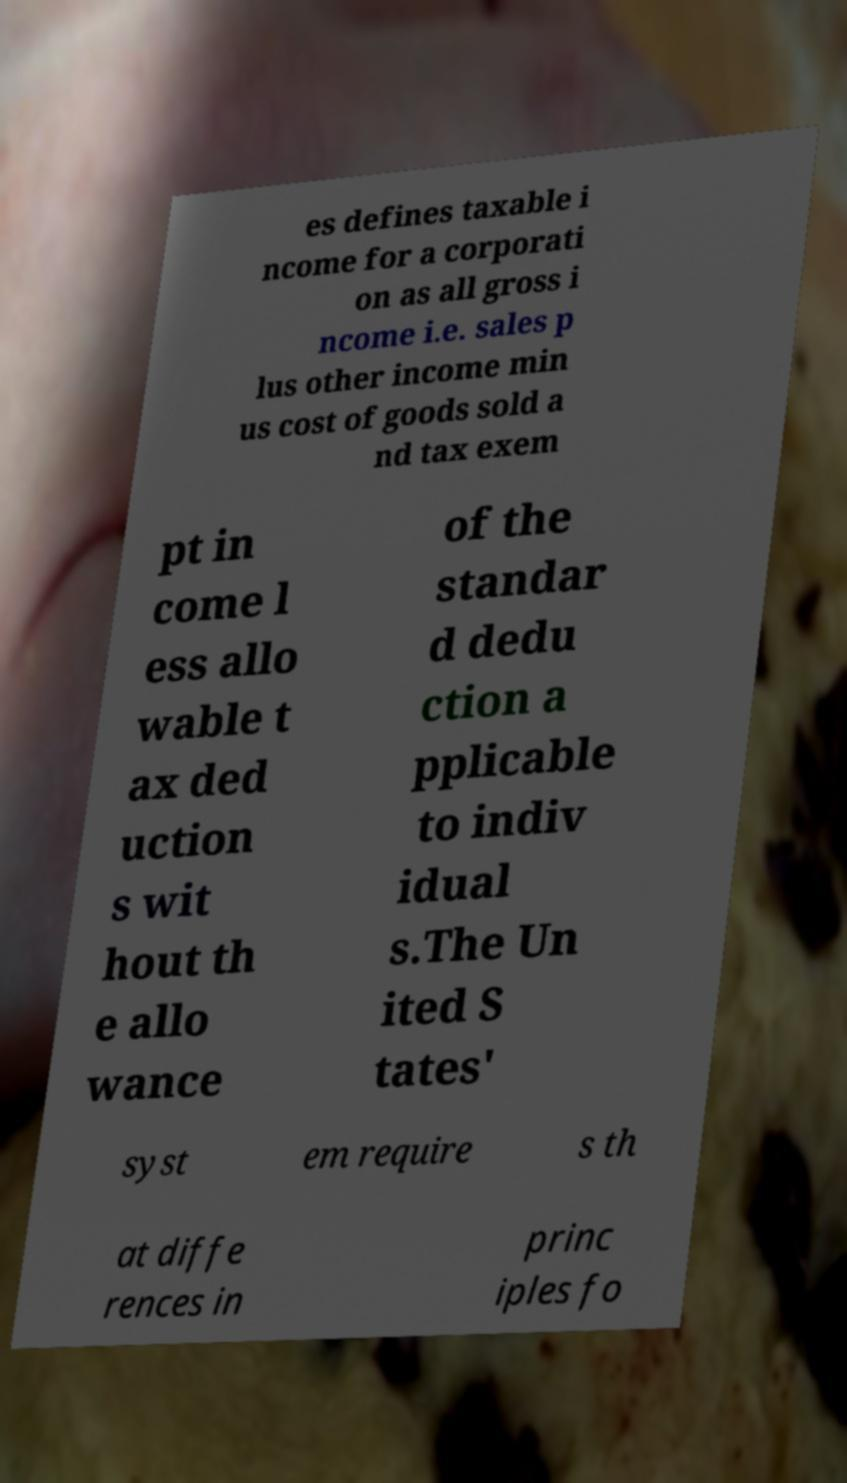Please read and relay the text visible in this image. What does it say? es defines taxable i ncome for a corporati on as all gross i ncome i.e. sales p lus other income min us cost of goods sold a nd tax exem pt in come l ess allo wable t ax ded uction s wit hout th e allo wance of the standar d dedu ction a pplicable to indiv idual s.The Un ited S tates' syst em require s th at diffe rences in princ iples fo 